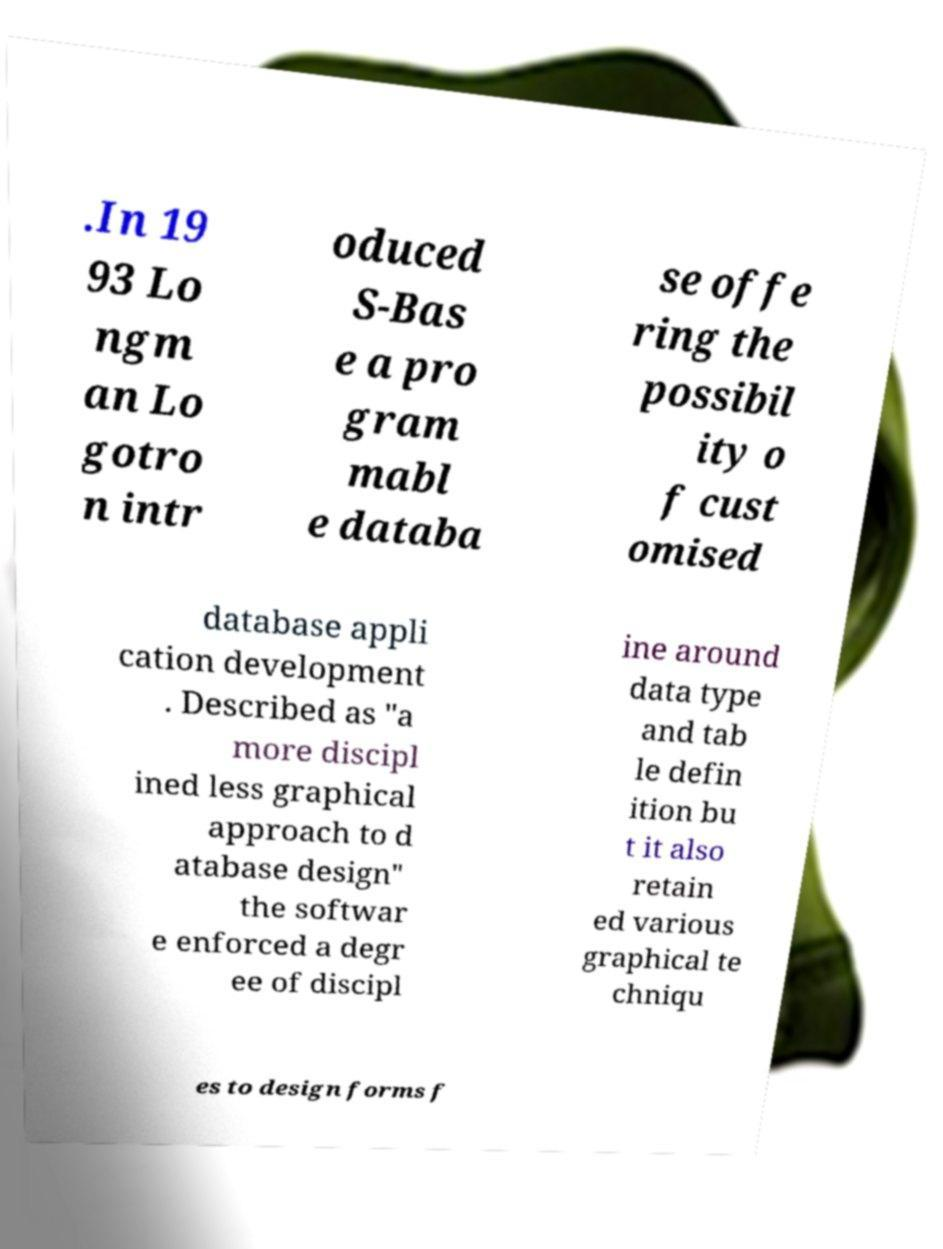Could you extract and type out the text from this image? .In 19 93 Lo ngm an Lo gotro n intr oduced S-Bas e a pro gram mabl e databa se offe ring the possibil ity o f cust omised database appli cation development . Described as "a more discipl ined less graphical approach to d atabase design" the softwar e enforced a degr ee of discipl ine around data type and tab le defin ition bu t it also retain ed various graphical te chniqu es to design forms f 